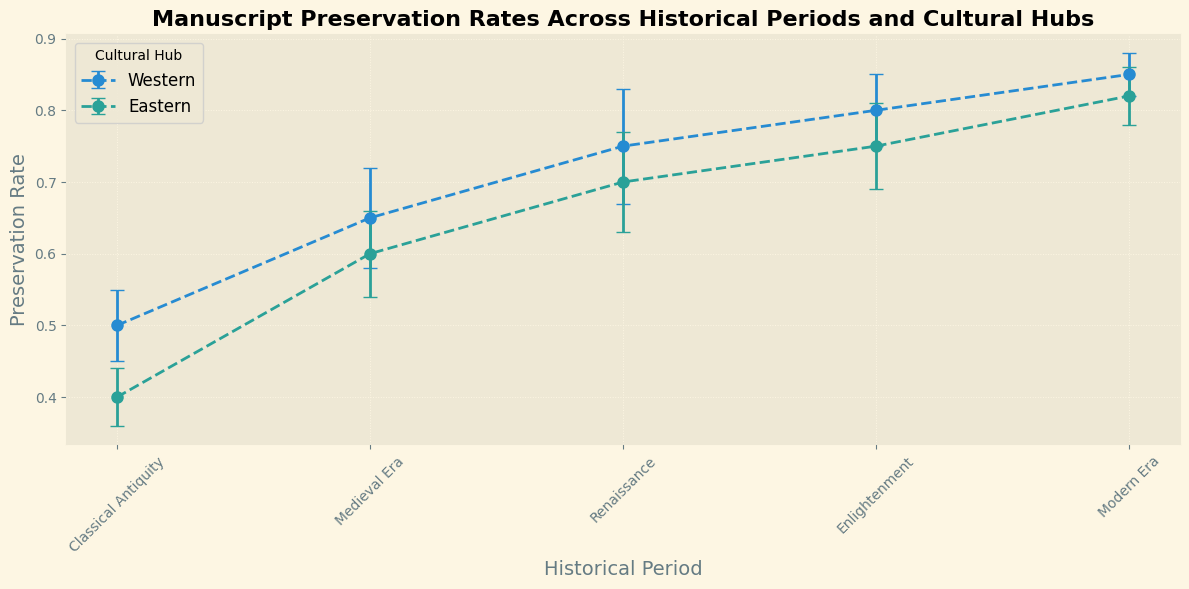What's the preservation rate of manuscripts in the Western cultural hub during the Renaissance? Looking at the data for the Renaissance period, the preservation rate for the Western hub is shown visually on the graph.
Answer: 0.75 What is the difference in preservation rates between the Eastern cultural hub and the Western cultural hub in the Medieval Era? The preservation rate for the Western hub during the Medieval Era is 0.65, whereas for the Eastern hub it is 0.6. The difference is 0.65 - 0.6.
Answer: 0.05 Which cultural hub has a higher preservation rate in the Modern Era? Comparing the preservation rates in the Modern Era, the Western hub has a rate of 0.85 and the Eastern hub has a rate of 0.82. The Western hub has a higher rate.
Answer: Western During the Classical Antiquity period, what is the combined preservation rate of manuscripts for both cultural hubs? The preservation rate for the Western hub is 0.5 and for the Eastern hub is 0.4. Adding them together gives 0.5 + 0.4.
Answer: 0.9 During which period do the Western and Eastern cultural hubs have the smallest difference in preservation rates? Visually comparing the differences across periods, the smallest difference is during the Enlightenment, where the Western rate is 0.8 and the Eastern rate is 0.75. The difference is 0.05.
Answer: Enlightenment What's the average preservation rate of manuscripts for the Eastern cultural hub during the periods shown? The preservation rates for the Eastern cultural hub across the periods are 0.4 (Classical Antiquity), 0.6 (Medieval Era), 0.7 (Renaissance), 0.75 (Enlightenment), 0.82 (Modern Era). The average is (0.4 + 0.6 + 0.7 + 0.75 + 0.82) / 5.
Answer: 0.654 What’s the total margin of error across all periods for the Western cultural hub? Summing the error margins for the Western hub across periods: 0.05 + 0.07 + 0.08 + 0.05 + 0.03.
Answer: 0.28 In which period does the Eastern cultural hub have the highest preservation rate? The highest preservation rate for the Eastern hub is found by looking at the peaks in the graph. It is in the Modern Era with a rate of 0.82.
Answer: Modern Era Compare the preservation rates of the Eastern cultural hub in the Renaissance and Enlightenment periods. Which is greater and by how much? The preservation rate during the Renaissance is 0.7 and during the Enlightenment is 0.75. The difference is 0.75 - 0.7.
Answer: Enlightenment, 0.05 